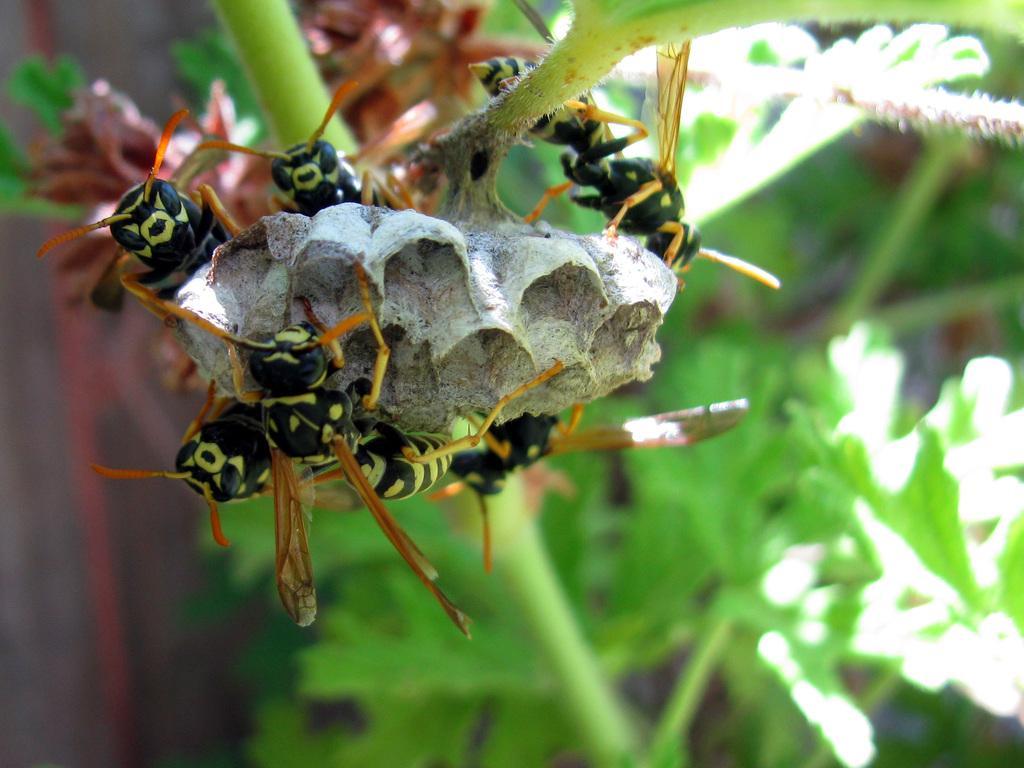In one or two sentences, can you explain what this image depicts? There are some insects on the flower of a plant as we can see in the middle of this image. 